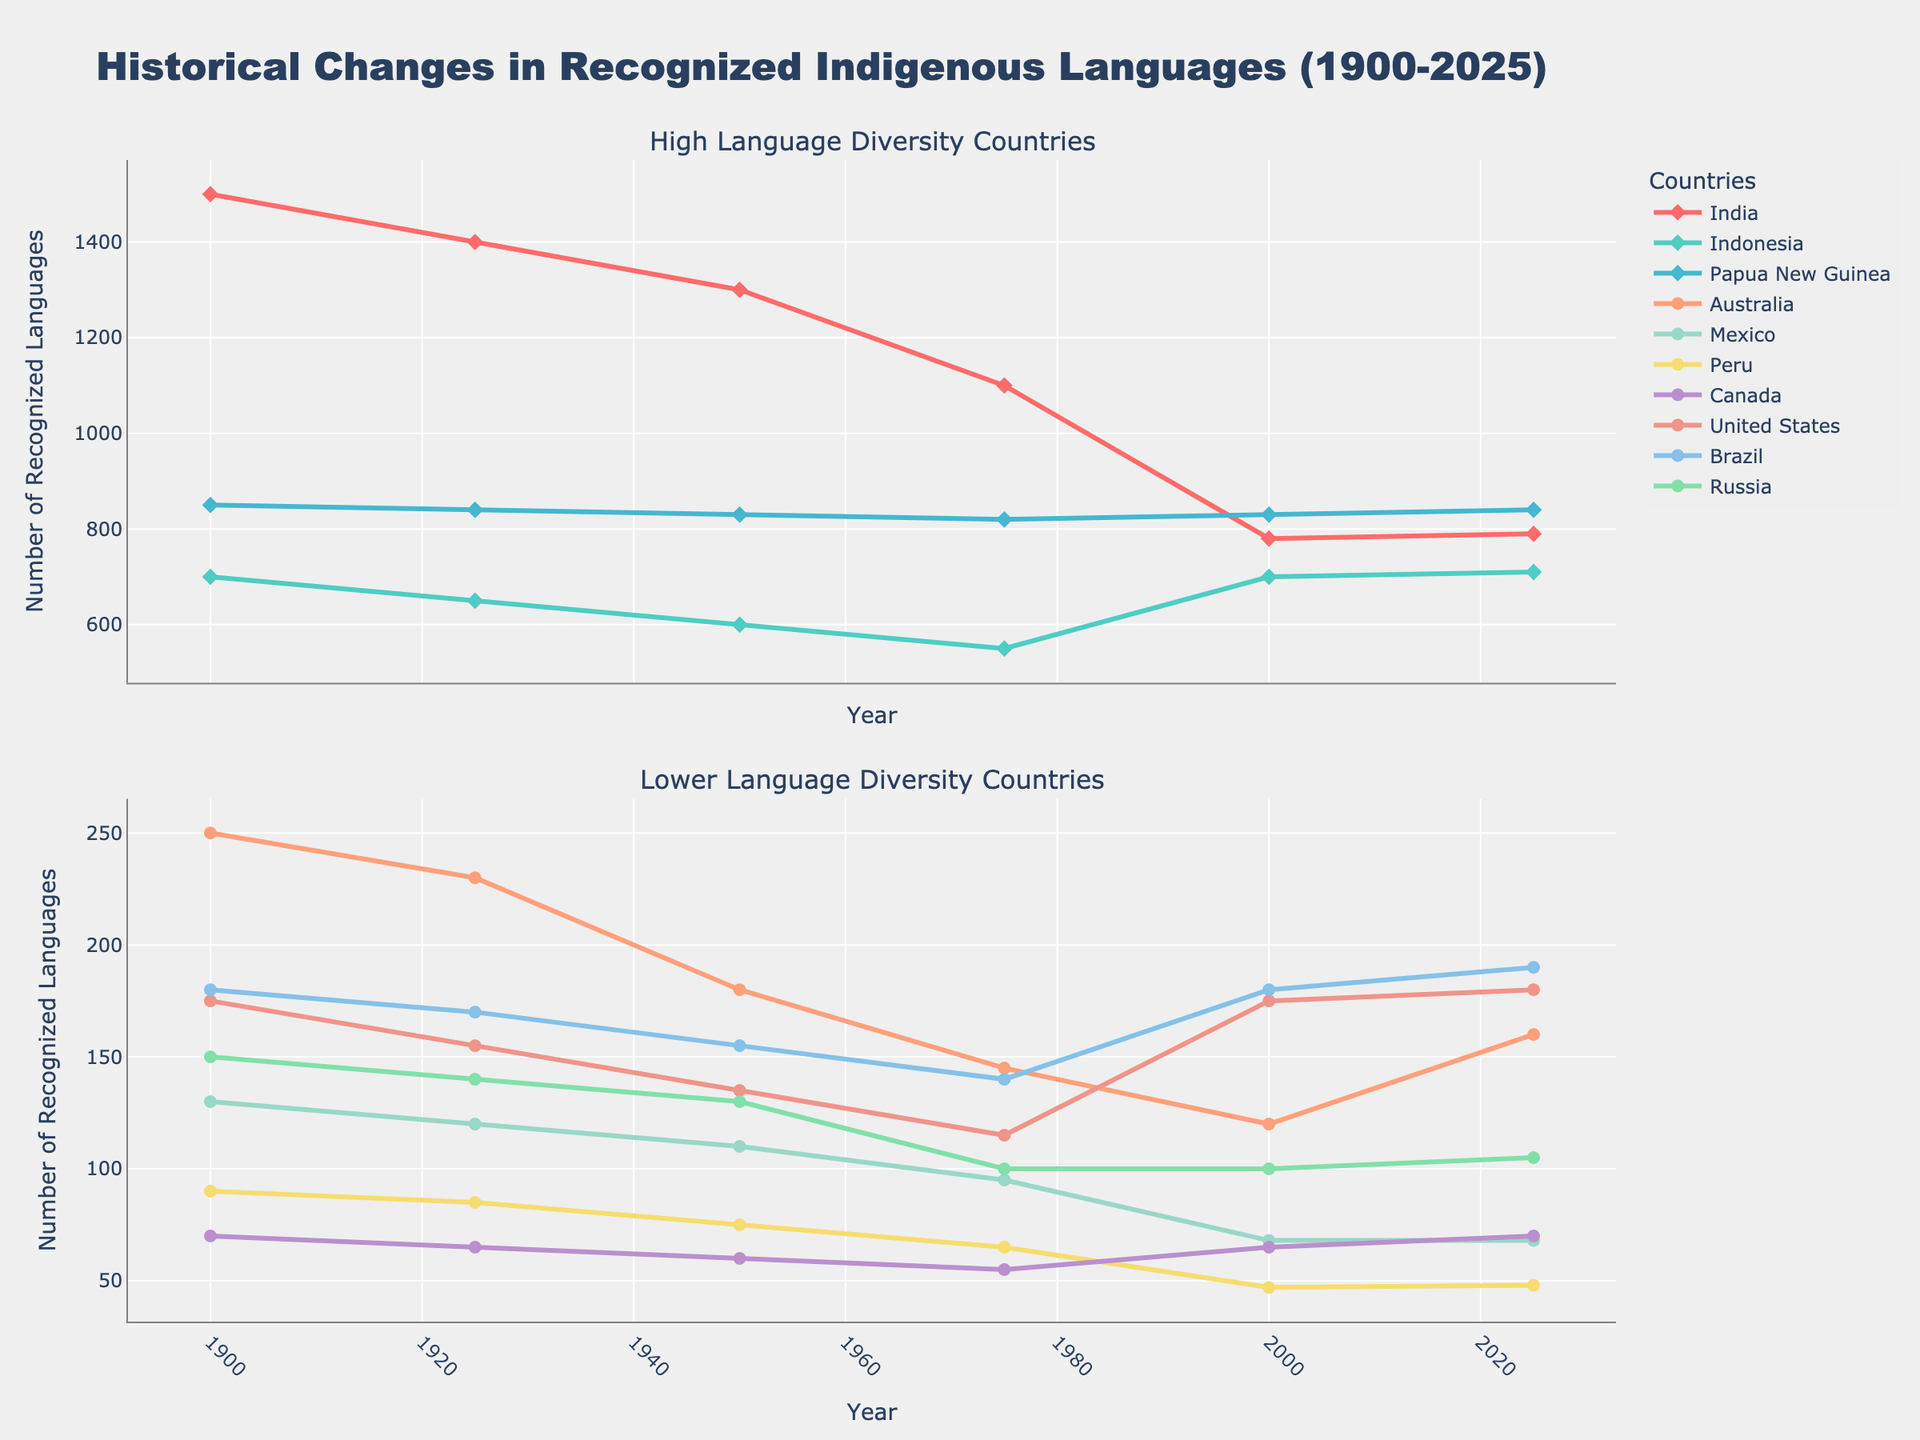What's the trend in the number of recognized indigenous languages in Canada over time? From 1900 to 1975, the number of recognized languages in Canada decreases from 70 to 55. From 2000 onward, this number increases slightly from 65 to 70 by 2025.
Answer: Decrease, then slight increase Which country experienced a significant increase in the number of recognized indigenous languages between 2000 and 2025? The United States shows a significant increase in the number of recognized indigenous languages, from 175 to 180, and Brazil shows an increase from 180 to 190. Both rises are significant near the end of the timeline.
Answer: United States, Brazil What is the average number of recognized indigenous languages in Mexico between 1900 and 2025? The numbers for Mexico from 1900 to 2025 are 130, 120, 110, 95, 68, and 68. Summing these up gives 591, and dividing by 6, we get 98.5.
Answer: 98.5 Which country had the highest number of recognized indigenous languages in 1950? In 1950, the data shows that India had 1300 recognized indigenous languages, which is the highest among all listed countries for that year.
Answer: India By how much did the number of recognized indigenous languages in Russia decrease from 1900 to the present? In 1900, Russia had 150 recognized languages, which decreased to 105 in 2025. The decrease is 150 - 105, which equals 45.
Answer: 45 Is there any country where the number of recognized indigenous languages remained constant from 2000 to 2025? The data shows that in Mexico, the number of recognized languages remained constant at 68 from 2000 to 2025.
Answer: Mexico Compare the number of recognized indigenous languages in Australia and Canada in 2000. Which country had more? In 2000, Australia had 120 recognized languages, while Canada had 65. Australia had more recognized languages than Canada in 2000.
Answer: Australia What is the general trend for recognized indigenous languages in India between 1900 and the present? From 1900 to 2000, there is a downward trend, with the number decreasing from 1500 to 780. However, from 2000 to 2025, there is a slight increase from 780 to 790.
Answer: Decreasing, slight increase 